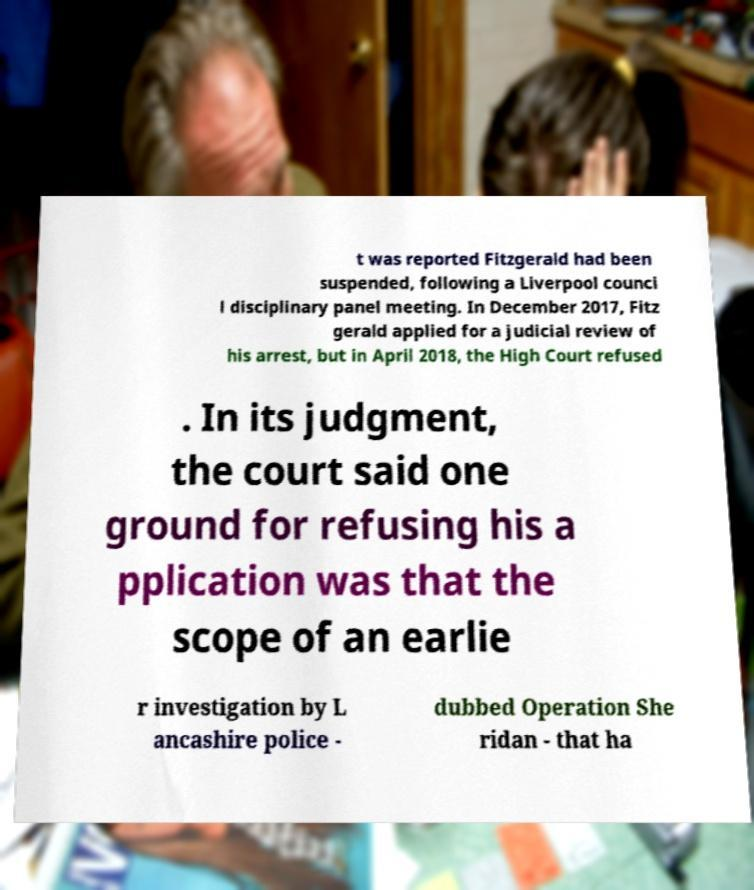Could you assist in decoding the text presented in this image and type it out clearly? t was reported Fitzgerald had been suspended, following a Liverpool counci l disciplinary panel meeting. In December 2017, Fitz gerald applied for a judicial review of his arrest, but in April 2018, the High Court refused . In its judgment, the court said one ground for refusing his a pplication was that the scope of an earlie r investigation by L ancashire police - dubbed Operation She ridan - that ha 